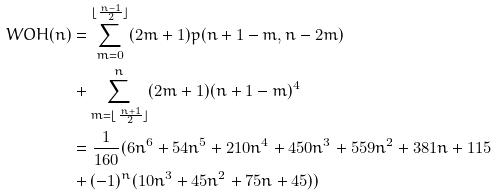<formula> <loc_0><loc_0><loc_500><loc_500>W O H ( n ) & = \sum _ { m = 0 } ^ { \lfloor \frac { n - 1 } { 2 } \rfloor } ( 2 m + 1 ) p ( n + 1 - m , n - 2 m ) \\ & + \sum _ { m = \lfloor \frac { n + 1 } { 2 } \rfloor } ^ { n } ( 2 m + 1 ) ( n + 1 - m ) ^ { 4 } \\ & = \frac { 1 } { 1 6 0 } ( 6 n ^ { 6 } + 5 4 n ^ { 5 } + 2 1 0 n ^ { 4 } + 4 5 0 n ^ { 3 } + 5 5 9 n ^ { 2 } + 3 8 1 n + 1 1 5 \\ & + ( - 1 ) ^ { n } ( 1 0 n ^ { 3 } + 4 5 n ^ { 2 } + 7 5 n + 4 5 ) )</formula> 